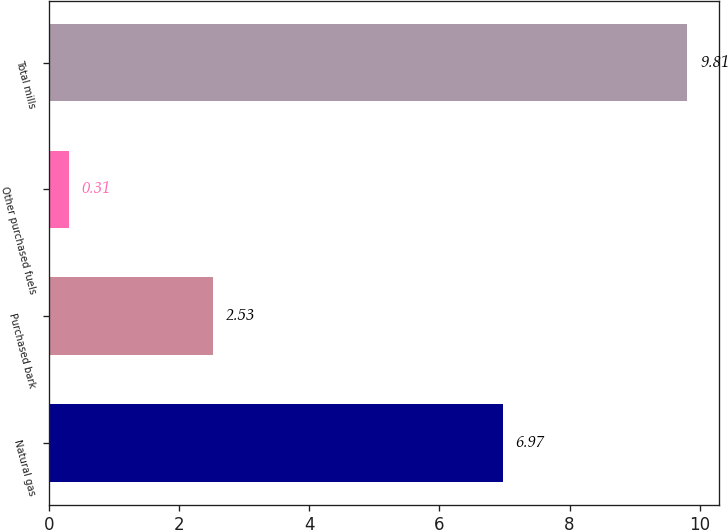Convert chart. <chart><loc_0><loc_0><loc_500><loc_500><bar_chart><fcel>Natural gas<fcel>Purchased bark<fcel>Other purchased fuels<fcel>Total mills<nl><fcel>6.97<fcel>2.53<fcel>0.31<fcel>9.81<nl></chart> 